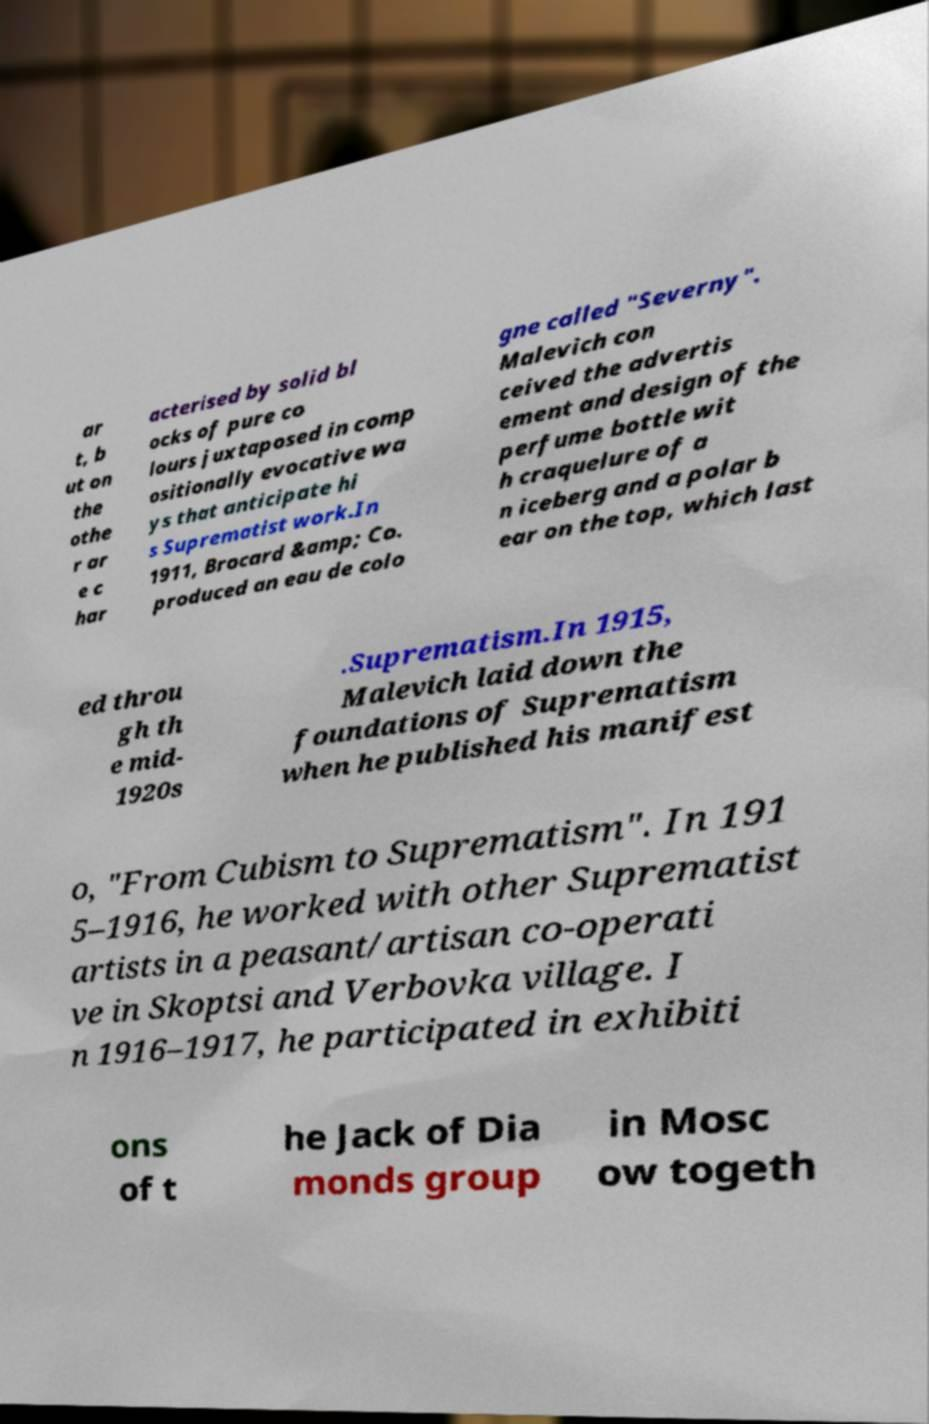Please read and relay the text visible in this image. What does it say? ar t, b ut on the othe r ar e c har acterised by solid bl ocks of pure co lours juxtaposed in comp ositionally evocative wa ys that anticipate hi s Suprematist work.In 1911, Brocard &amp; Co. produced an eau de colo gne called "Severny". Malevich con ceived the advertis ement and design of the perfume bottle wit h craquelure of a n iceberg and a polar b ear on the top, which last ed throu gh th e mid- 1920s .Suprematism.In 1915, Malevich laid down the foundations of Suprematism when he published his manifest o, "From Cubism to Suprematism". In 191 5–1916, he worked with other Suprematist artists in a peasant/artisan co-operati ve in Skoptsi and Verbovka village. I n 1916–1917, he participated in exhibiti ons of t he Jack of Dia monds group in Mosc ow togeth 